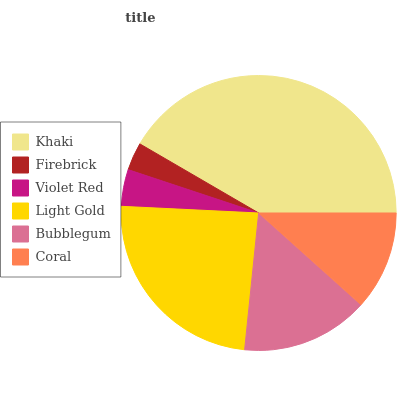Is Firebrick the minimum?
Answer yes or no. Yes. Is Khaki the maximum?
Answer yes or no. Yes. Is Violet Red the minimum?
Answer yes or no. No. Is Violet Red the maximum?
Answer yes or no. No. Is Violet Red greater than Firebrick?
Answer yes or no. Yes. Is Firebrick less than Violet Red?
Answer yes or no. Yes. Is Firebrick greater than Violet Red?
Answer yes or no. No. Is Violet Red less than Firebrick?
Answer yes or no. No. Is Bubblegum the high median?
Answer yes or no. Yes. Is Coral the low median?
Answer yes or no. Yes. Is Khaki the high median?
Answer yes or no. No. Is Light Gold the low median?
Answer yes or no. No. 